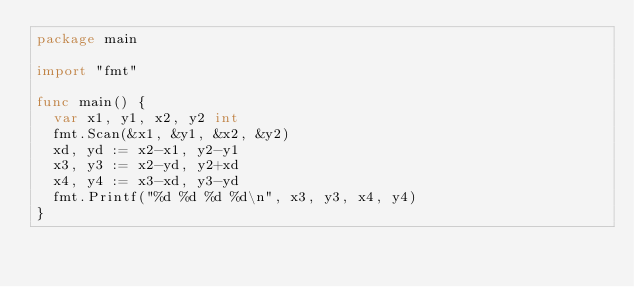Convert code to text. <code><loc_0><loc_0><loc_500><loc_500><_Go_>package main

import "fmt"

func main() {
	var x1, y1, x2, y2 int
	fmt.Scan(&x1, &y1, &x2, &y2)
	xd, yd := x2-x1, y2-y1
	x3, y3 := x2-yd, y2+xd
	x4, y4 := x3-xd, y3-yd
	fmt.Printf("%d %d %d %d\n", x3, y3, x4, y4)
}
</code> 